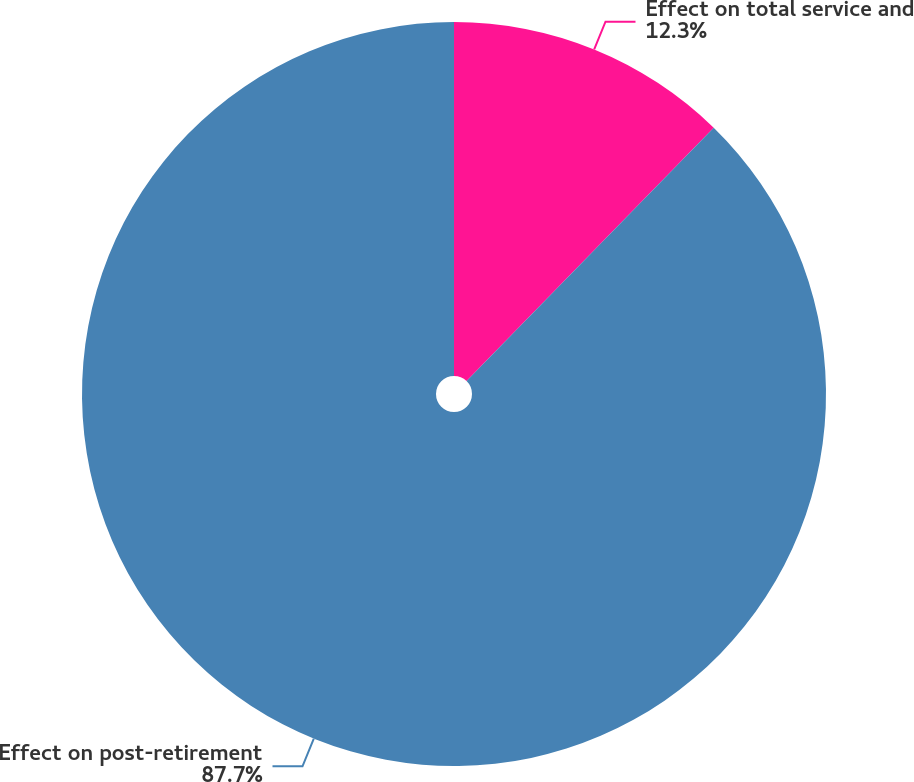<chart> <loc_0><loc_0><loc_500><loc_500><pie_chart><fcel>Effect on total service and<fcel>Effect on post-retirement<nl><fcel>12.3%<fcel>87.7%<nl></chart> 